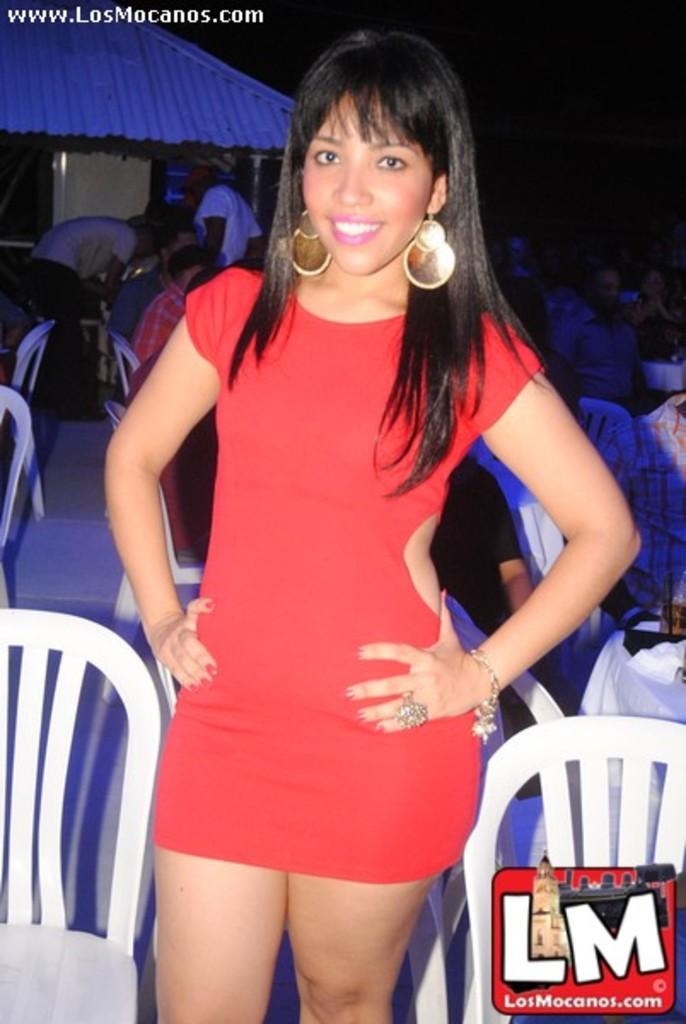<image>
Describe the image concisely. www.LosMocanos.com is the link captioned above this photo. 